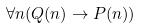Convert formula to latex. <formula><loc_0><loc_0><loc_500><loc_500>\forall n ( Q ( n ) \rightarrow P ( n ) )</formula> 